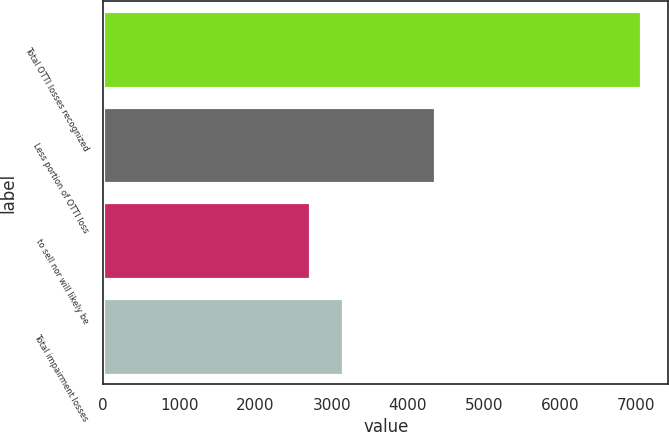<chart> <loc_0><loc_0><loc_500><loc_500><bar_chart><fcel>Total OTTI losses recognized<fcel>Less portion of OTTI loss<fcel>to sell nor will likely be<fcel>Total impairment losses<nl><fcel>7068<fcel>4356<fcel>2712<fcel>3147.6<nl></chart> 